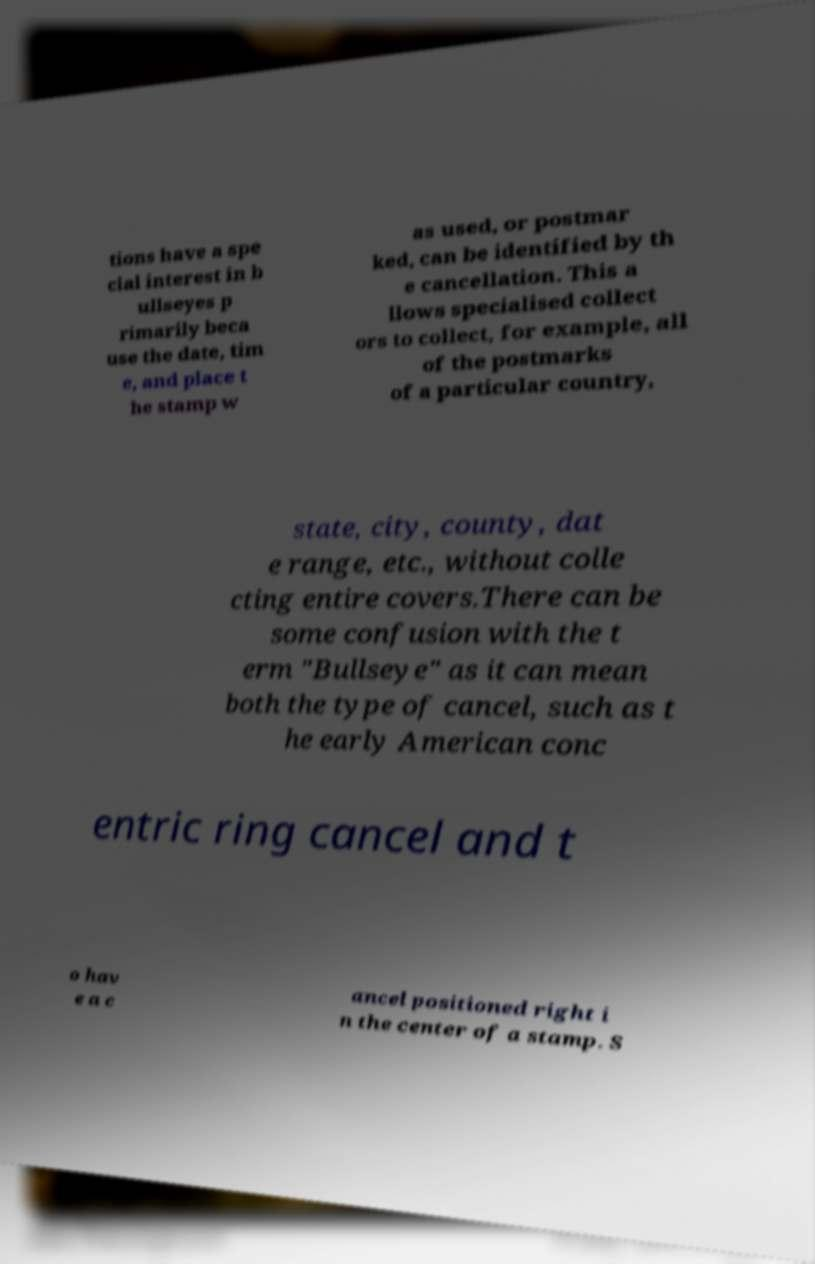What messages or text are displayed in this image? I need them in a readable, typed format. tions have a spe cial interest in b ullseyes p rimarily beca use the date, tim e, and place t he stamp w as used, or postmar ked, can be identified by th e cancellation. This a llows specialised collect ors to collect, for example, all of the postmarks of a particular country, state, city, county, dat e range, etc., without colle cting entire covers.There can be some confusion with the t erm "Bullseye" as it can mean both the type of cancel, such as t he early American conc entric ring cancel and t o hav e a c ancel positioned right i n the center of a stamp. S 